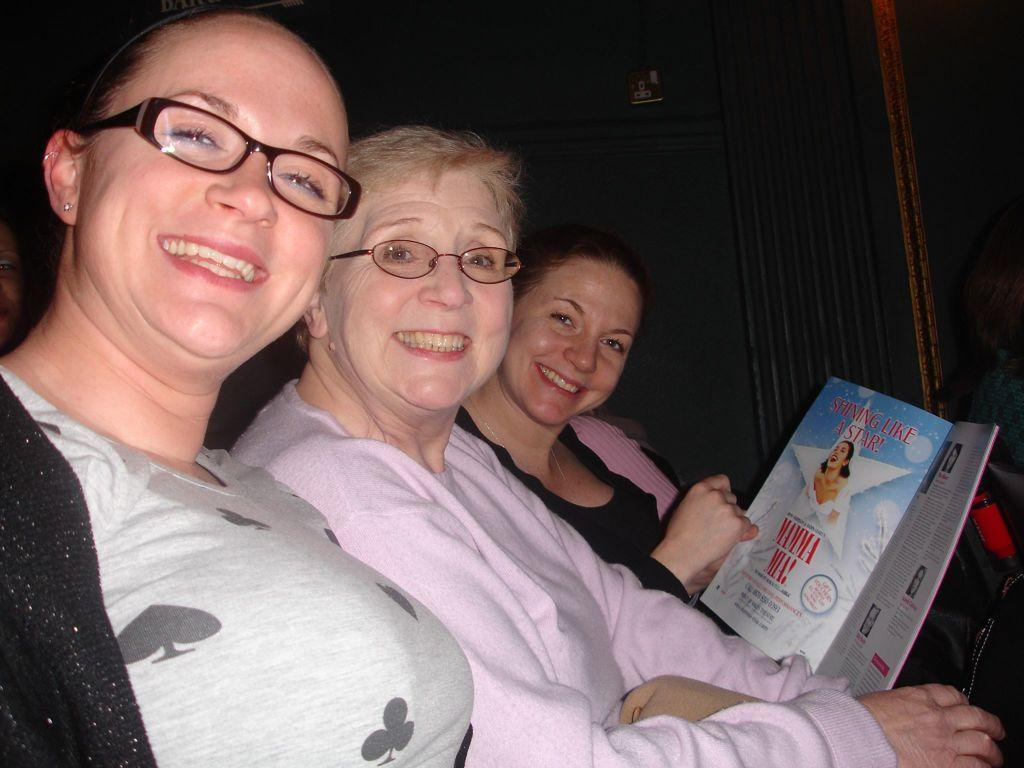How many women are in the image? There are three women in the image. What are the women doing in the image? The women are sitting and smiling. Can you describe what one of the women is holding? One of the women is holding a book in her hand. What can be seen in the background of the image? There is a wall in the background of the image. Are there any cobwebs visible on the wall in the image? There is no mention of cobwebs in the provided facts, and therefore we cannot determine if any are present in the image. 